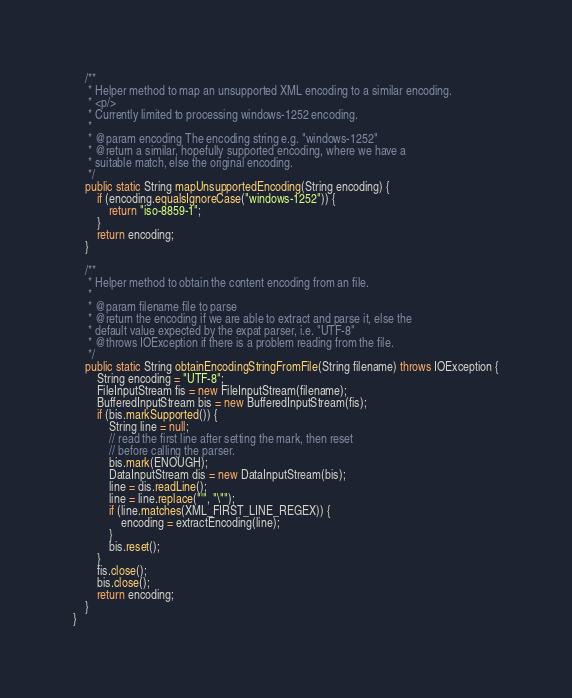<code> <loc_0><loc_0><loc_500><loc_500><_Java_>

    /**
     * Helper method to map an unsupported XML encoding to a similar encoding.
     * <p/>
     * Currently limited to processing windows-1252 encoding.
     *
     * @param encoding The encoding string e.g. "windows-1252"
     * @return a similar, hopefully supported encoding, where we have a
     * suitable match, else the original encoding.
     */
    public static String mapUnsupportedEncoding(String encoding) {
        if (encoding.equalsIgnoreCase("windows-1252")) {
            return "iso-8859-1";
        }
        return encoding;
    }

    /**
     * Helper method to obtain the content encoding from an file.
     *
     * @param filename file to parse
     * @return the encoding if we are able to extract and parse it, else the
     * default value expected by the expat parser, i.e. "UTF-8"
     * @throws IOException if there is a problem reading from the file.
     */
    public static String obtainEncodingStringFromFile(String filename) throws IOException {
        String encoding = "UTF-8";
        FileInputStream fis = new FileInputStream(filename);
        BufferedInputStream bis = new BufferedInputStream(fis);
        if (bis.markSupported()) {
            String line = null;
            // read the first line after setting the mark, then reset
            // before calling the parser.
            bis.mark(ENOUGH);
            DataInputStream dis = new DataInputStream(bis);
            line = dis.readLine();
            line = line.replace("'", "\"");
            if (line.matches(XML_FIRST_LINE_REGEX)) {
                encoding = extractEncoding(line);
            }
            bis.reset();
        }
        fis.close();
        bis.close();
        return encoding;
    }
}
</code> 